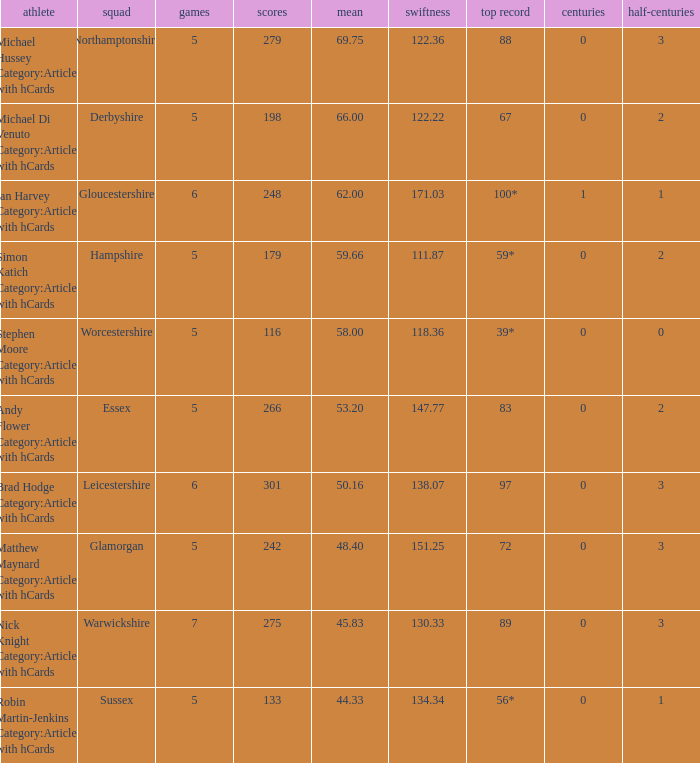If the highest score is 88, what are the 50s? 3.0. 